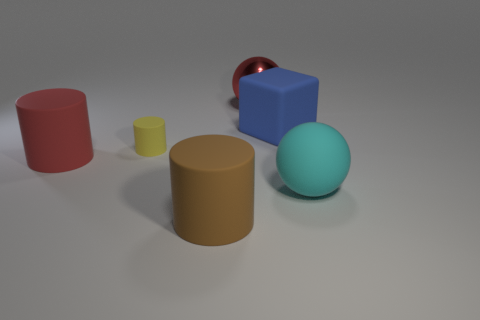What is the size of the ball behind the big ball that is in front of the large red rubber object?
Keep it short and to the point. Large. Is the number of big red balls greater than the number of big cyan metallic spheres?
Your response must be concise. Yes. Is the number of red things that are in front of the yellow rubber cylinder greater than the number of big blue objects that are right of the large blue rubber object?
Your response must be concise. Yes. There is a matte thing that is both to the left of the cyan object and on the right side of the big red shiny ball; how big is it?
Provide a short and direct response. Large. What number of balls are the same size as the brown thing?
Offer a very short reply. 2. There is a cylinder that is the same color as the big shiny sphere; what is its material?
Provide a short and direct response. Rubber. Does the big red thing that is on the left side of the metallic thing have the same shape as the large cyan object?
Provide a succinct answer. No. Are there fewer brown objects to the right of the big block than large red balls?
Offer a terse response. Yes. Are there any rubber cylinders of the same color as the metal thing?
Your answer should be compact. Yes. There is a shiny object; does it have the same shape as the large red thing that is on the left side of the yellow object?
Provide a short and direct response. No. 